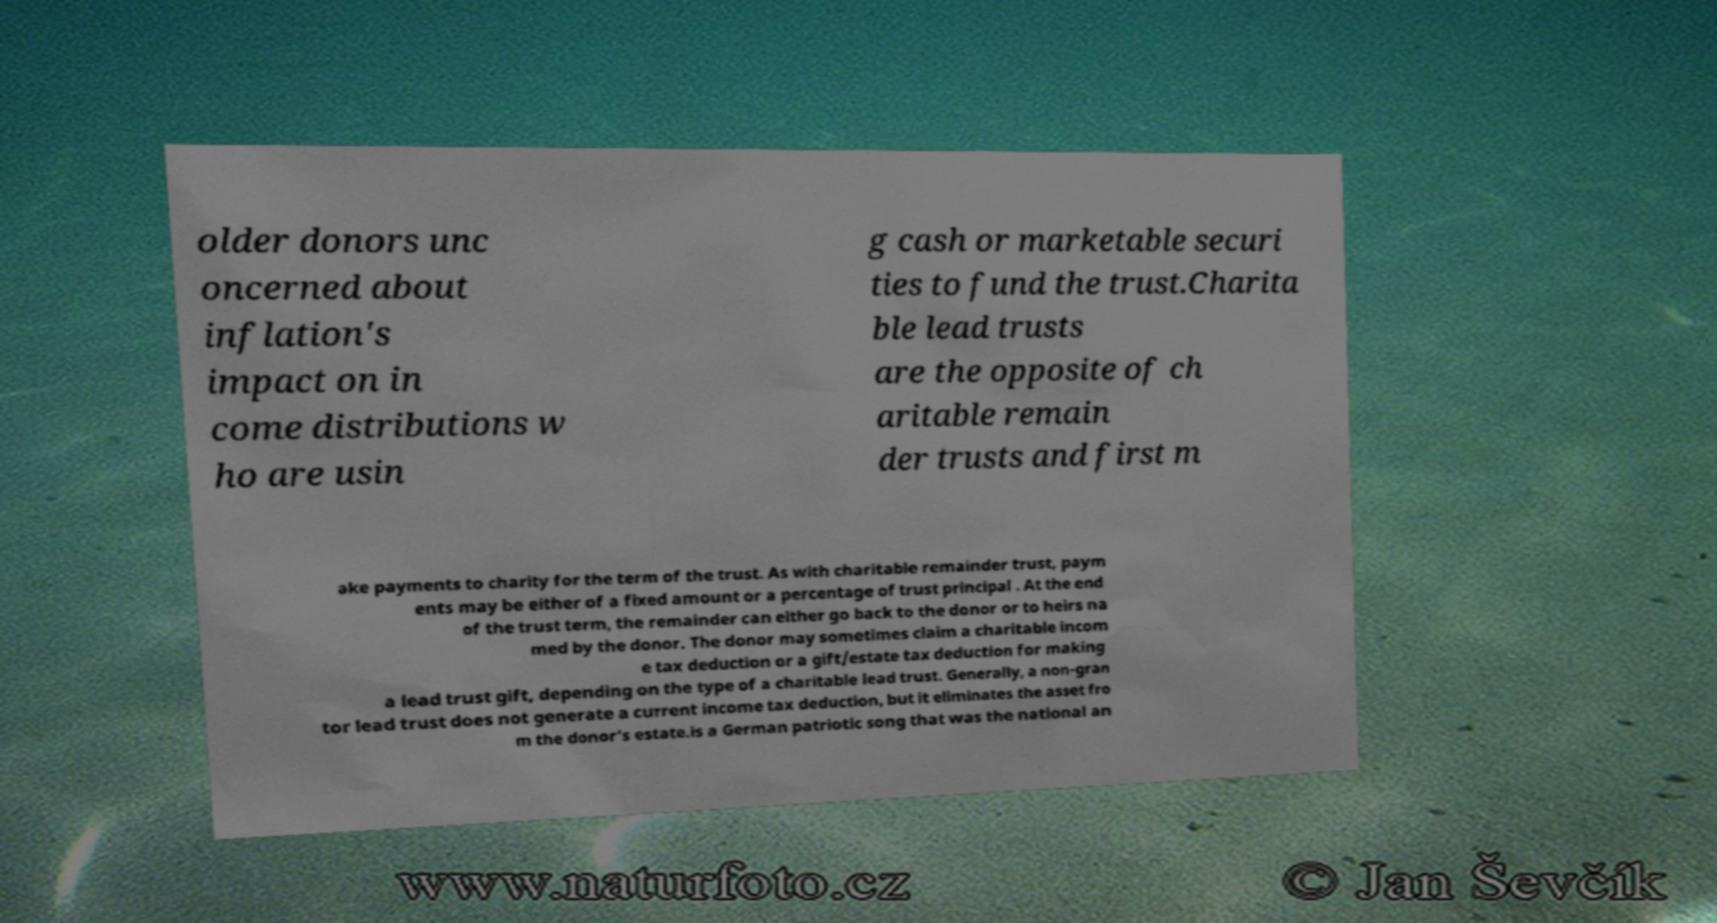Can you accurately transcribe the text from the provided image for me? older donors unc oncerned about inflation's impact on in come distributions w ho are usin g cash or marketable securi ties to fund the trust.Charita ble lead trusts are the opposite of ch aritable remain der trusts and first m ake payments to charity for the term of the trust. As with charitable remainder trust, paym ents may be either of a fixed amount or a percentage of trust principal . At the end of the trust term, the remainder can either go back to the donor or to heirs na med by the donor. The donor may sometimes claim a charitable incom e tax deduction or a gift/estate tax deduction for making a lead trust gift, depending on the type of a charitable lead trust. Generally, a non-gran tor lead trust does not generate a current income tax deduction, but it eliminates the asset fro m the donor's estate.is a German patriotic song that was the national an 